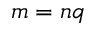<formula> <loc_0><loc_0><loc_500><loc_500>m = n q</formula> 